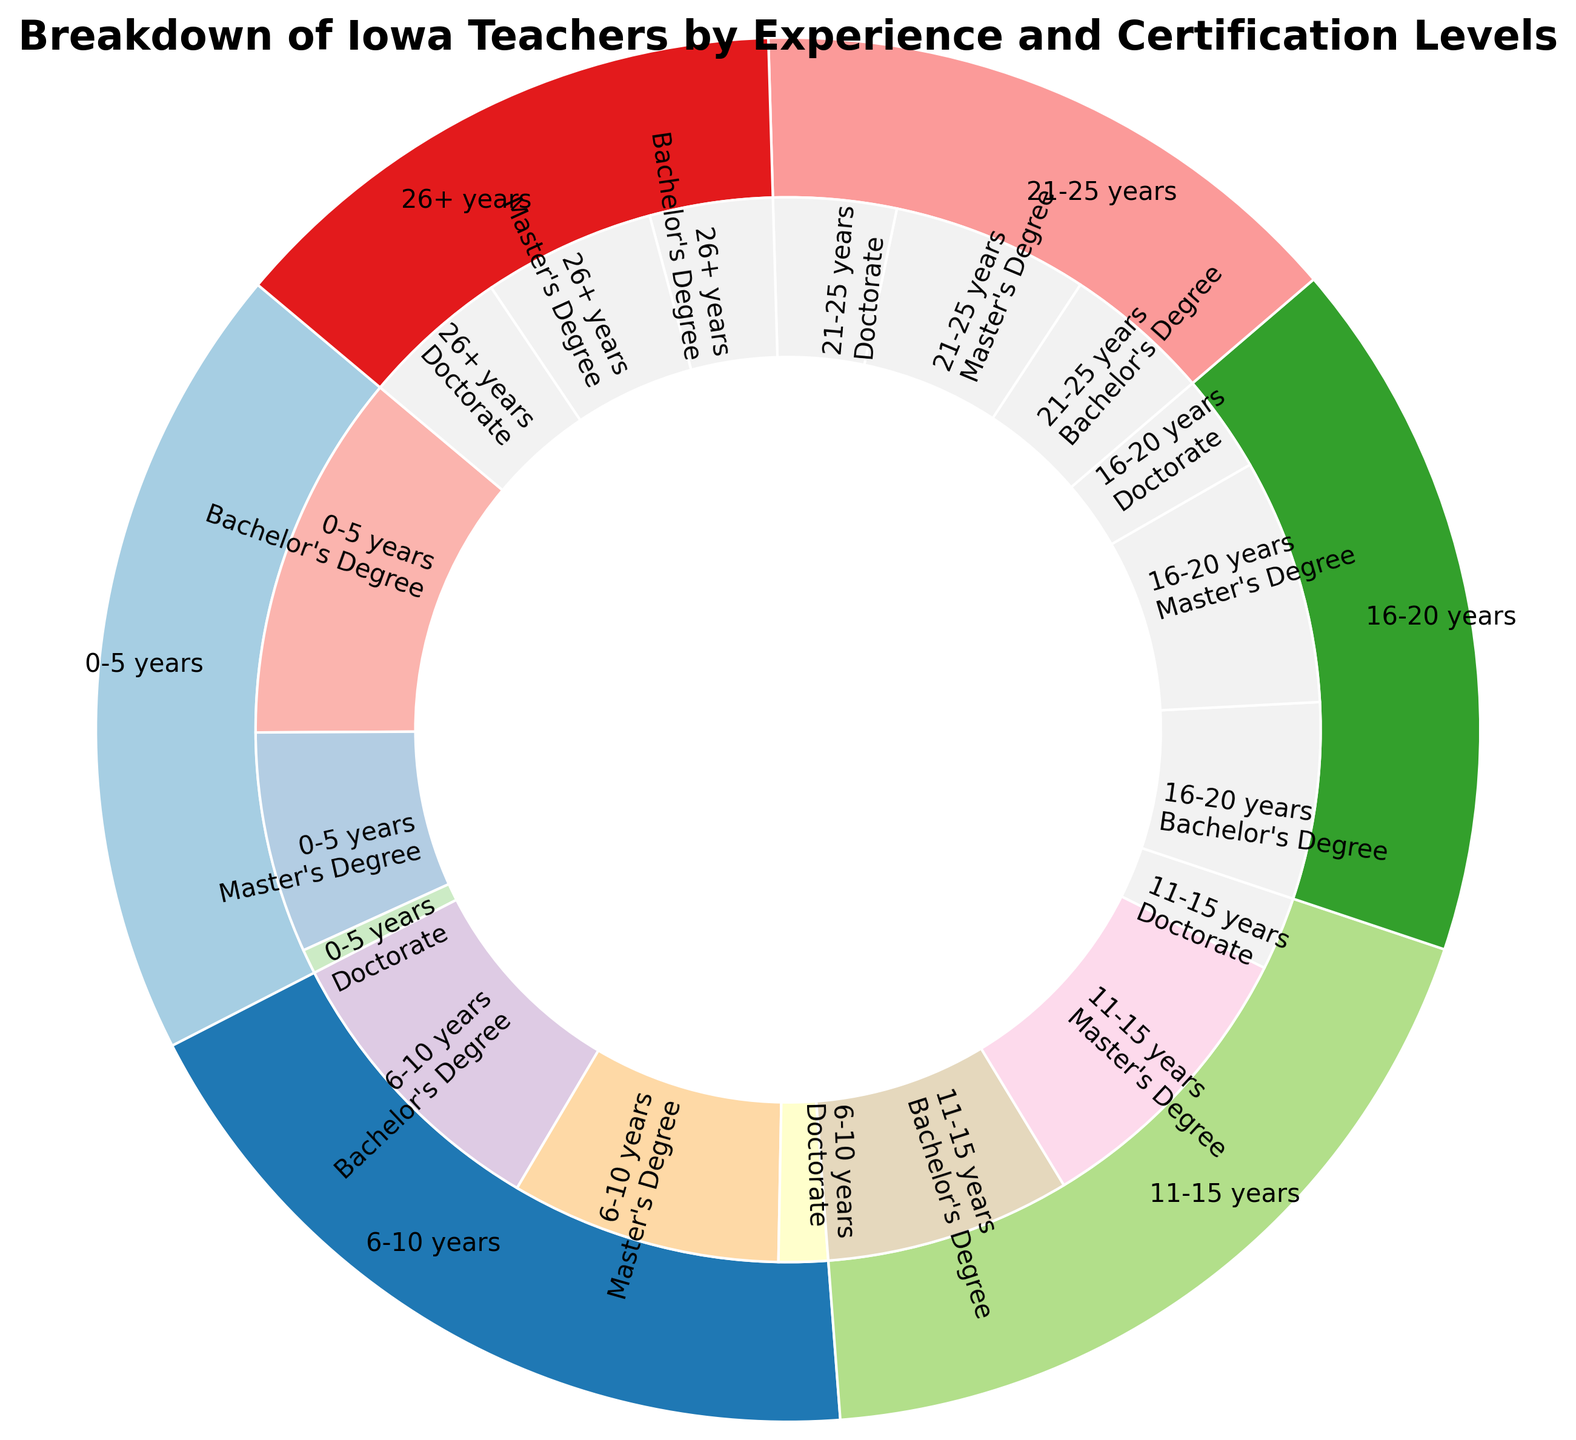How many teachers have 6-10 years of experience? Sum up the counts for Bachelor's Degree (1200), Master's Degree (1100), and Doctorate (200) within the 6-10 years experience category. 1200 + 1100 + 200 = 2500
Answer: 2500 Which experience group has the highest number of teachers with Doctorate degrees? Compare the counts of Doctorate degrees across all experience groups: 0-5 years (100), 6-10 years (200), 11-15 years (300), 16-20 years (400), 21-25 years (500), and 26+ years (600). 26+ years has the highest count of 600.
Answer: 26+ years What is the total number of teachers with a Master's Degree across all experience levels? Sum up the counts for Master's Degree: 0-5 years (900), 6-10 years (1100), 11-15 years (1200), 16-20 years (1000), 21-25 years (800), and 26+ years (700). 900 + 1100 + 1200 + 1000 + 800 + 700 = 5700
Answer: 5700 Between teachers with 11-15 years and 16-20 years of experience, which group has more teachers with a Bachelor's Degree? Compare the Bachelor's Degree counts: 11-15 years (1000) and 16-20 years (800). 11-15 years has more with 1000.
Answer: 11-15 years What are the outer ring colors used for the different experience groups? The outer ring colors vary based on the experience groups, typically using distinct colors from a preset palette such as tones from paired colors.
Answer: Various distinct colors from paired palette How many teachers have either 16-20 years or 21-25 years of experience? Sum the counts for both experience groups: 16-20 years (800 + 1000 + 400) and 21-25 years (600 + 800 + 500). 2200 (16-20 years) + 1900 (21-25 years) = 4100
Answer: 4100 Which certification level has the least number of teachers in the 0-5 years experience group? Compare the counts within the 0-5 years group: Bachelor's Degree (1500), Master's Degree (900), and Doctorate (100). Doctorate has the least with 100.
Answer: Doctorate Is there a greater number of teachers with Doctorate degrees in the 21-25 years experience group compared to the 16-20 years experience group? Compare the counts for Doctorate degrees: 21-25 years (500) vs. 16-20 years (400). 21-25 years has more with 500.
Answer: Yes What percentage of teachers have 26+ years of experience out of the total number of teachers? Calculate the total number of teachers across all groups and find the percentage for 26+ years: Total = (1500 + 900 + 100 + 1200 + 1100 + 200 + 1000 + 1200 + 300 + 800 + 1000 + 400 + 600 + 800 + 500 + 500 + 700 + 600) = 13800. 26+ years total is (500 + 700 + 600) = 1800. Percentage = (1800 / 13800) * 100 ≈ 13.04%
Answer: 13.04% 